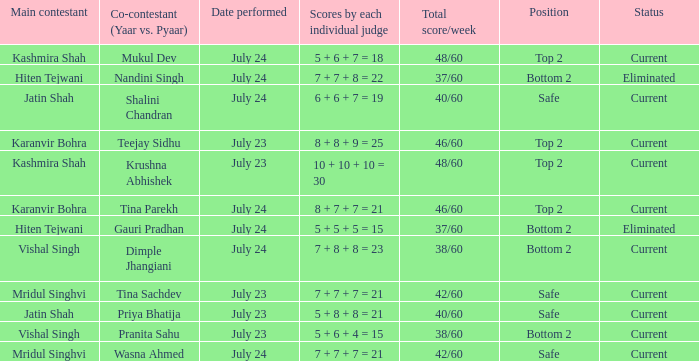What is Tina Sachdev's position? Safe. 